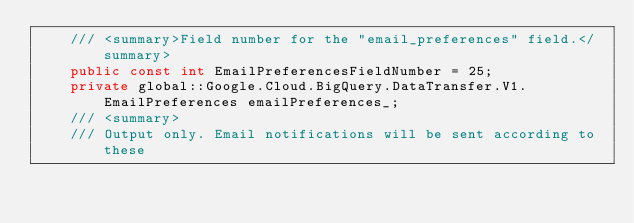<code> <loc_0><loc_0><loc_500><loc_500><_C#_>    /// <summary>Field number for the "email_preferences" field.</summary>
    public const int EmailPreferencesFieldNumber = 25;
    private global::Google.Cloud.BigQuery.DataTransfer.V1.EmailPreferences emailPreferences_;
    /// <summary>
    /// Output only. Email notifications will be sent according to these</code> 